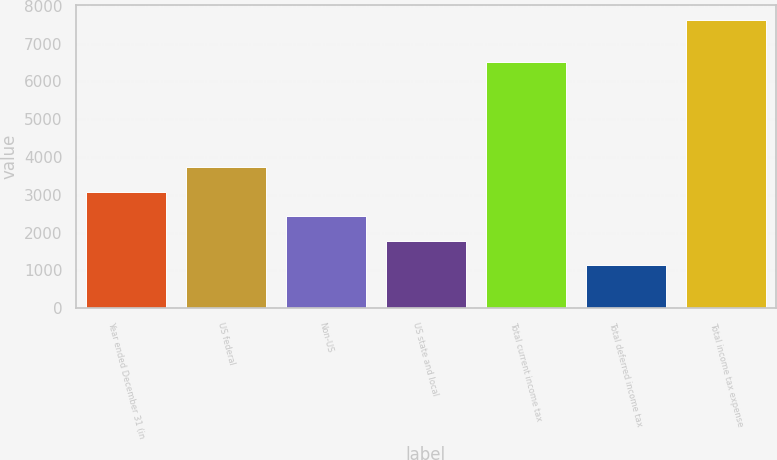Convert chart to OTSL. <chart><loc_0><loc_0><loc_500><loc_500><bar_chart><fcel>Year ended December 31 (in<fcel>US federal<fcel>Non-US<fcel>US state and local<fcel>Total current income tax<fcel>Total deferred income tax<fcel>Total income tax expense<nl><fcel>3080.9<fcel>3731.2<fcel>2430.6<fcel>1780.3<fcel>6503<fcel>1130<fcel>7633<nl></chart> 